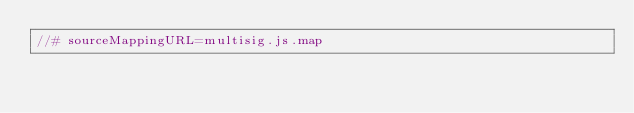<code> <loc_0><loc_0><loc_500><loc_500><_JavaScript_>//# sourceMappingURL=multisig.js.map</code> 